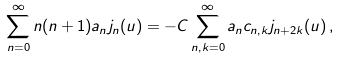Convert formula to latex. <formula><loc_0><loc_0><loc_500><loc_500>\sum _ { n = 0 } ^ { \infty } n ( n + 1 ) a _ { n } j _ { n } ( u ) = - C \sum _ { n , k = 0 } ^ { \infty } a _ { n } c _ { n , k } j _ { n + 2 k } ( u ) \, ,</formula> 